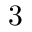Convert formula to latex. <formula><loc_0><loc_0><loc_500><loc_500>3</formula> 